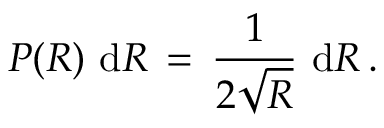<formula> <loc_0><loc_0><loc_500><loc_500>P ( R ) \, d R \, = \, \frac { 1 } { 2 \sqrt { R } } \, d R \, .</formula> 